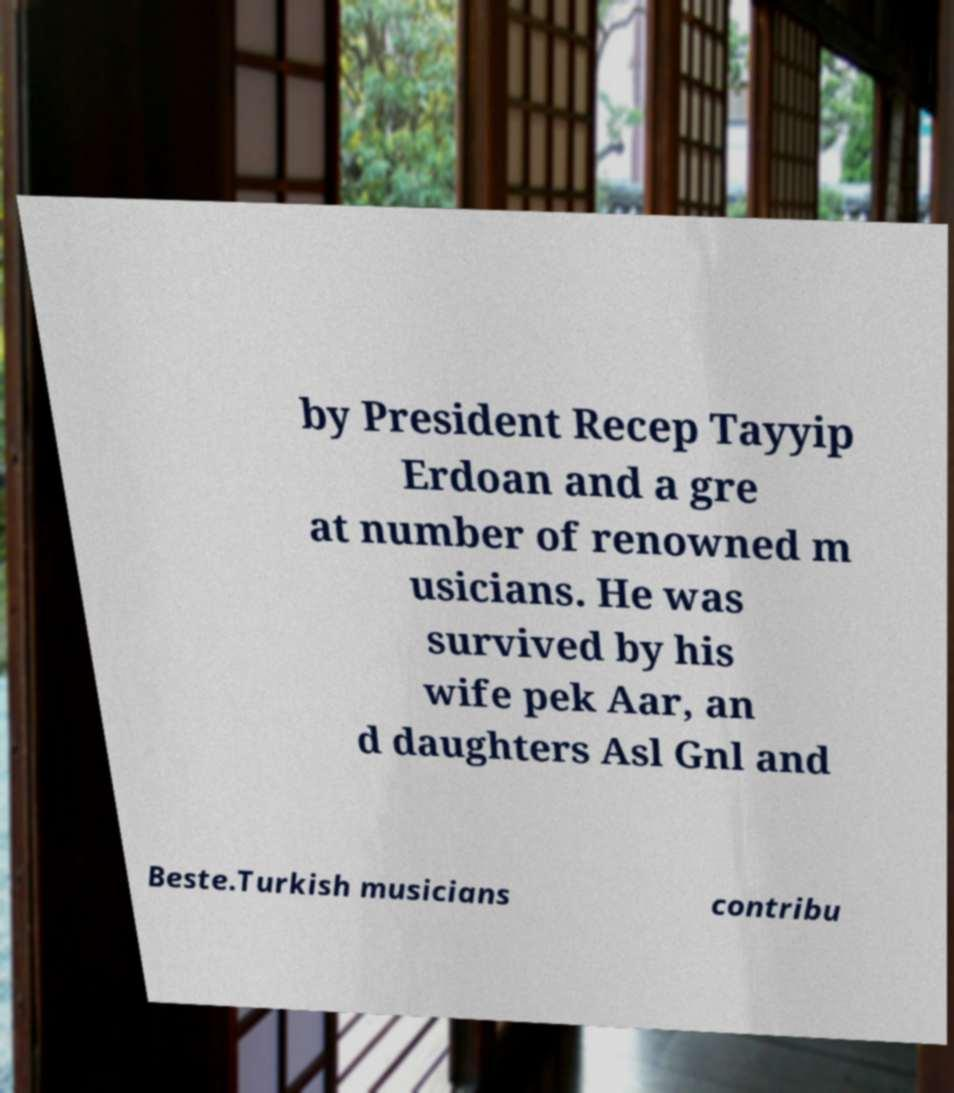I need the written content from this picture converted into text. Can you do that? by President Recep Tayyip Erdoan and a gre at number of renowned m usicians. He was survived by his wife pek Aar, an d daughters Asl Gnl and Beste.Turkish musicians contribu 